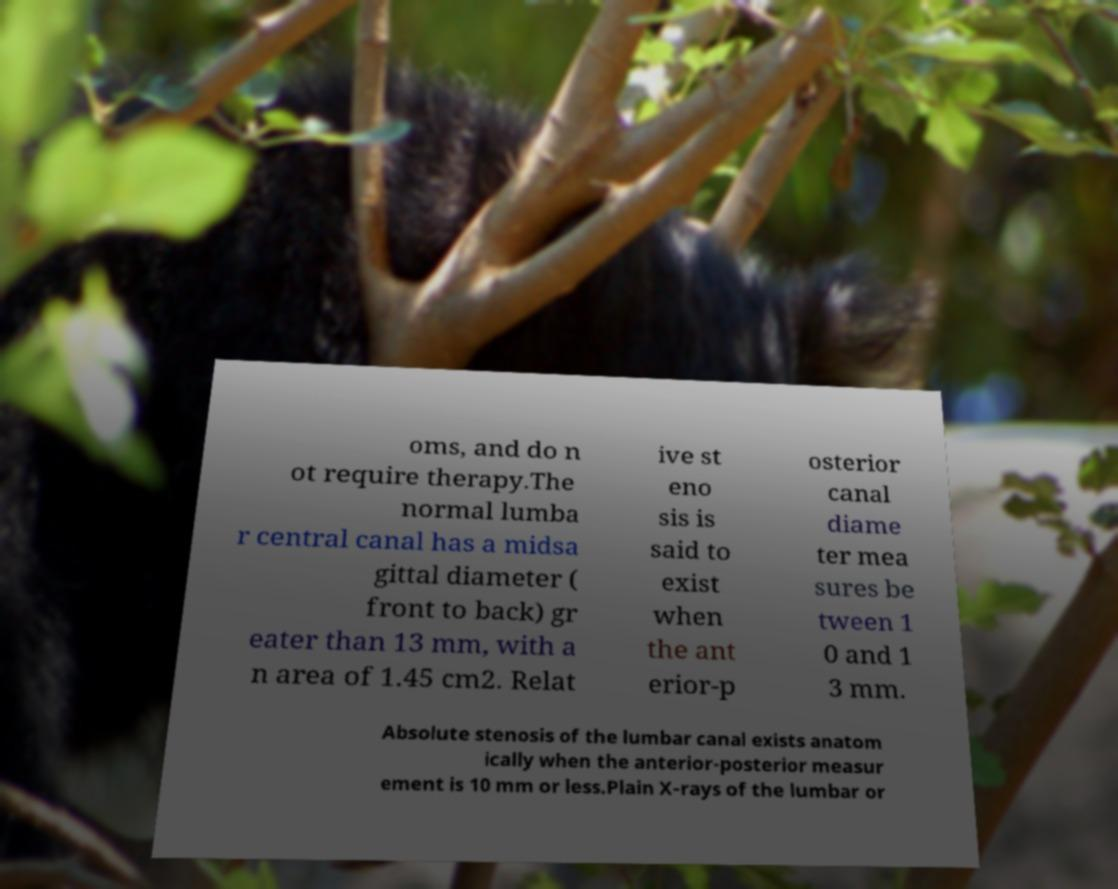Could you assist in decoding the text presented in this image and type it out clearly? oms, and do n ot require therapy.The normal lumba r central canal has a midsa gittal diameter ( front to back) gr eater than 13 mm, with a n area of 1.45 cm2. Relat ive st eno sis is said to exist when the ant erior-p osterior canal diame ter mea sures be tween 1 0 and 1 3 mm. Absolute stenosis of the lumbar canal exists anatom ically when the anterior-posterior measur ement is 10 mm or less.Plain X-rays of the lumbar or 